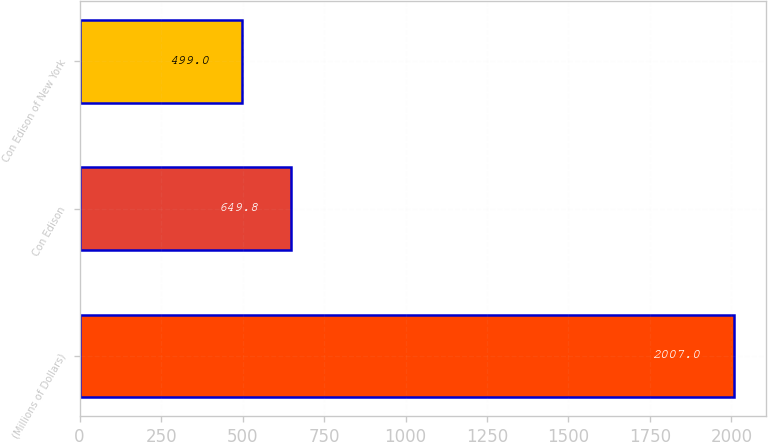Convert chart to OTSL. <chart><loc_0><loc_0><loc_500><loc_500><bar_chart><fcel>(Millions of Dollars)<fcel>Con Edison<fcel>Con Edison of New York<nl><fcel>2007<fcel>649.8<fcel>499<nl></chart> 